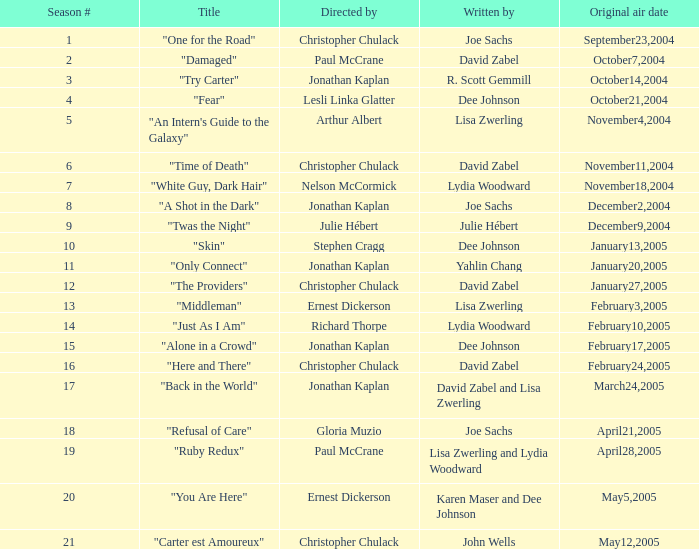Name who wrote the episode directed by arthur albert Lisa Zwerling. 